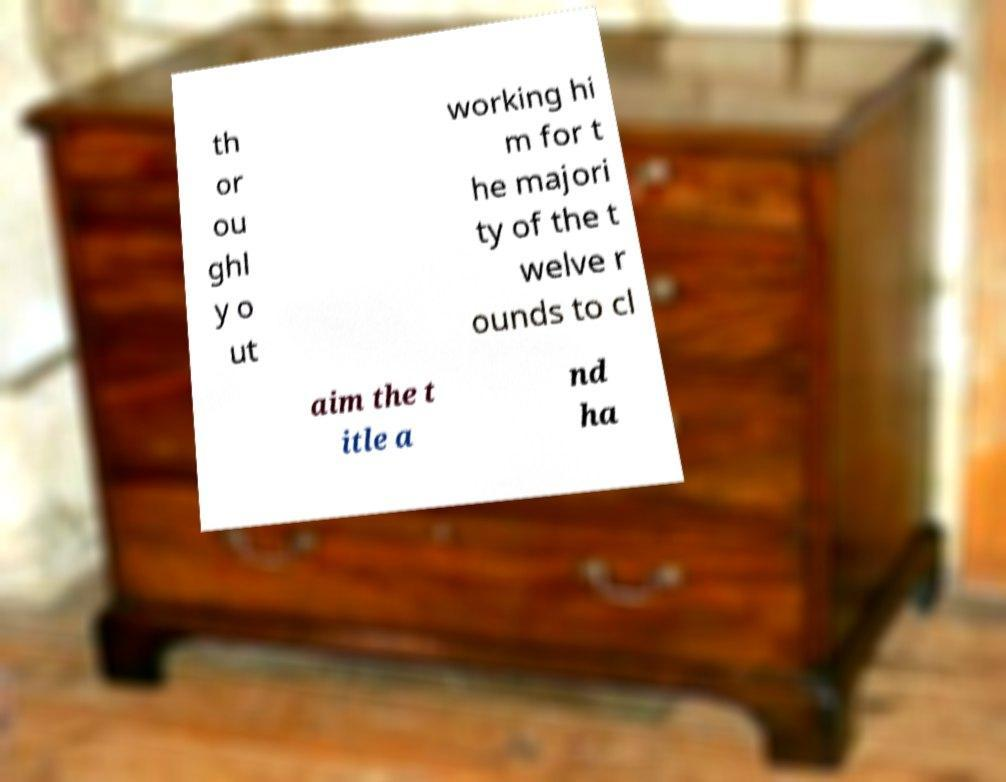Can you accurately transcribe the text from the provided image for me? th or ou ghl y o ut working hi m for t he majori ty of the t welve r ounds to cl aim the t itle a nd ha 